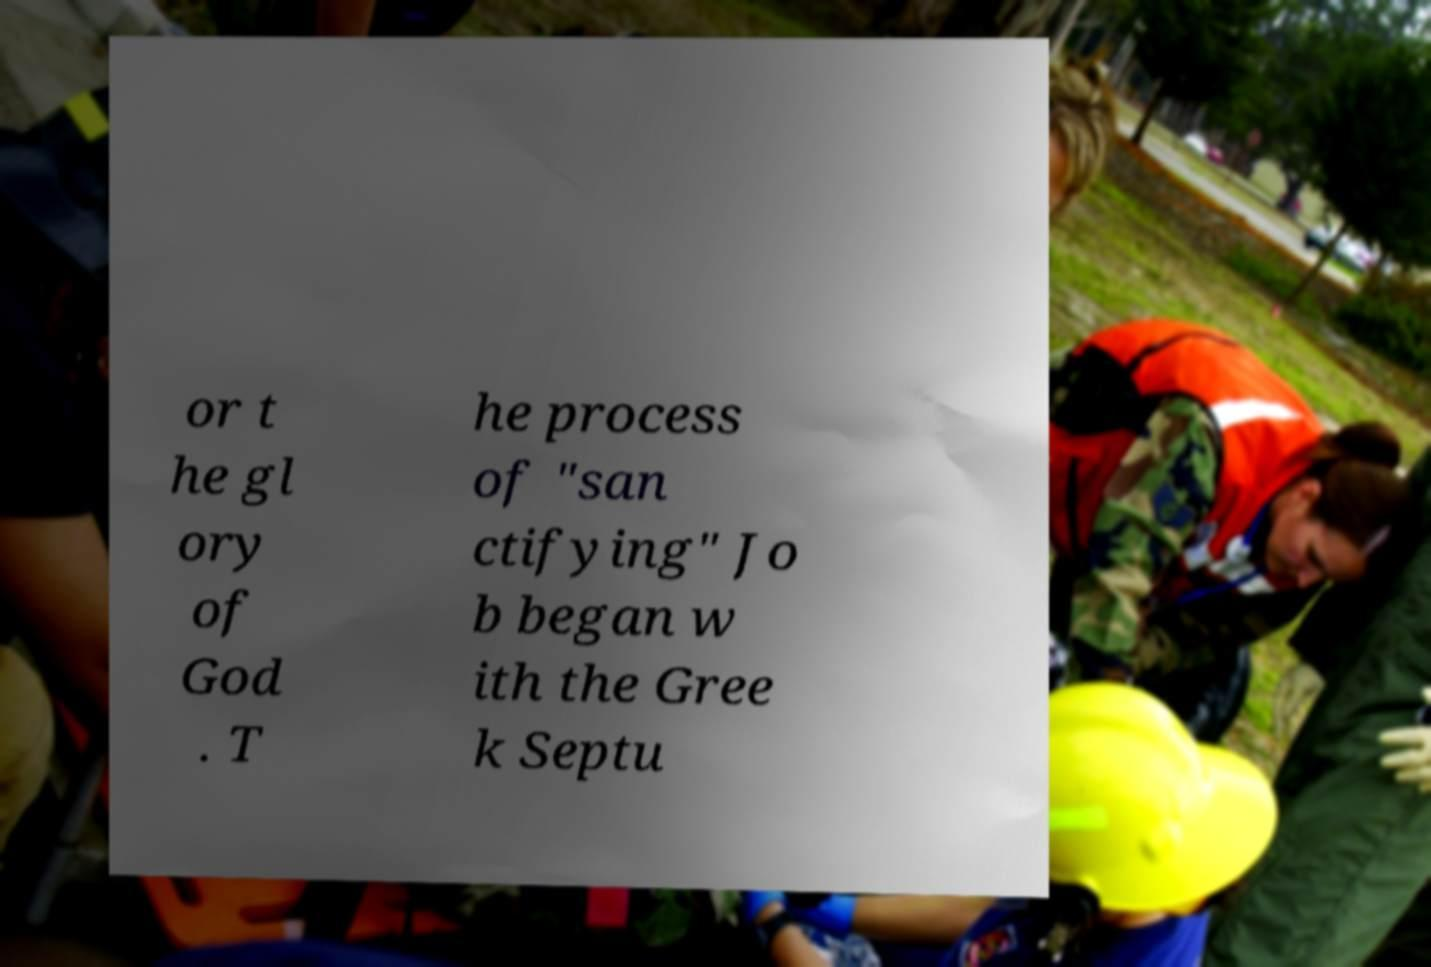Please read and relay the text visible in this image. What does it say? or t he gl ory of God . T he process of "san ctifying" Jo b began w ith the Gree k Septu 